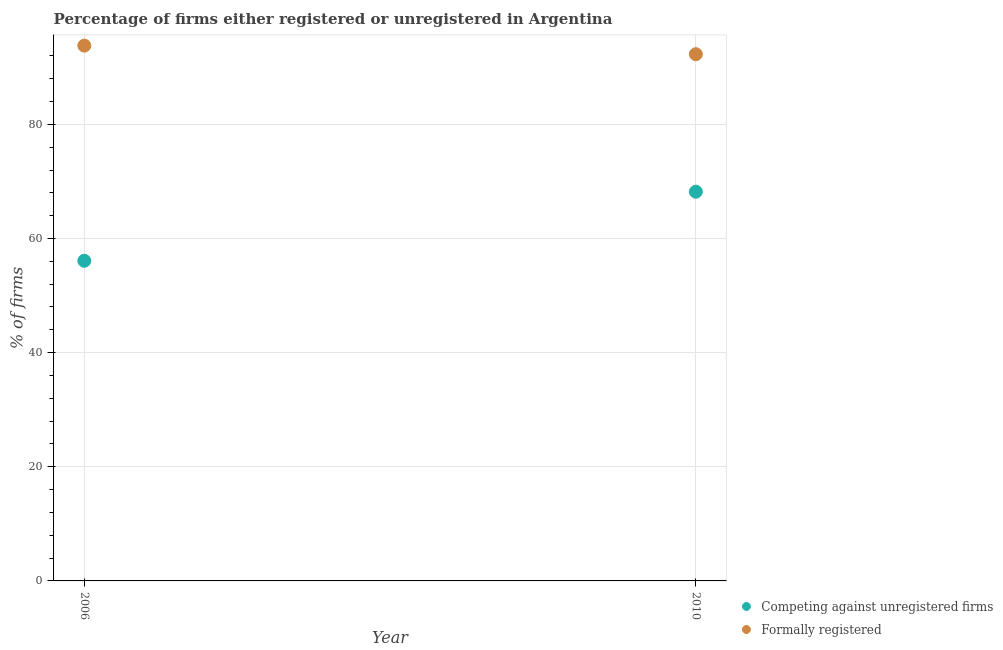Is the number of dotlines equal to the number of legend labels?
Your answer should be compact. Yes. What is the percentage of registered firms in 2006?
Provide a succinct answer. 56.1. Across all years, what is the maximum percentage of formally registered firms?
Your answer should be compact. 93.8. Across all years, what is the minimum percentage of registered firms?
Offer a terse response. 56.1. In which year was the percentage of formally registered firms maximum?
Provide a short and direct response. 2006. In which year was the percentage of formally registered firms minimum?
Make the answer very short. 2010. What is the total percentage of registered firms in the graph?
Your response must be concise. 124.3. What is the difference between the percentage of formally registered firms in 2010 and the percentage of registered firms in 2006?
Your answer should be compact. 36.2. What is the average percentage of formally registered firms per year?
Your answer should be very brief. 93.05. In the year 2010, what is the difference between the percentage of registered firms and percentage of formally registered firms?
Offer a terse response. -24.1. In how many years, is the percentage of formally registered firms greater than 72 %?
Make the answer very short. 2. What is the ratio of the percentage of formally registered firms in 2006 to that in 2010?
Offer a very short reply. 1.02. Is the percentage of formally registered firms in 2006 less than that in 2010?
Offer a very short reply. No. Is the percentage of registered firms strictly greater than the percentage of formally registered firms over the years?
Your response must be concise. No. How many dotlines are there?
Keep it short and to the point. 2. What is the difference between two consecutive major ticks on the Y-axis?
Make the answer very short. 20. Does the graph contain grids?
Your answer should be compact. Yes. Where does the legend appear in the graph?
Provide a short and direct response. Bottom right. How many legend labels are there?
Provide a short and direct response. 2. What is the title of the graph?
Offer a very short reply. Percentage of firms either registered or unregistered in Argentina. What is the label or title of the Y-axis?
Offer a very short reply. % of firms. What is the % of firms of Competing against unregistered firms in 2006?
Offer a very short reply. 56.1. What is the % of firms in Formally registered in 2006?
Your answer should be compact. 93.8. What is the % of firms of Competing against unregistered firms in 2010?
Offer a terse response. 68.2. What is the % of firms in Formally registered in 2010?
Make the answer very short. 92.3. Across all years, what is the maximum % of firms in Competing against unregistered firms?
Provide a short and direct response. 68.2. Across all years, what is the maximum % of firms of Formally registered?
Give a very brief answer. 93.8. Across all years, what is the minimum % of firms in Competing against unregistered firms?
Provide a short and direct response. 56.1. Across all years, what is the minimum % of firms in Formally registered?
Provide a succinct answer. 92.3. What is the total % of firms of Competing against unregistered firms in the graph?
Give a very brief answer. 124.3. What is the total % of firms in Formally registered in the graph?
Your answer should be very brief. 186.1. What is the difference between the % of firms in Competing against unregistered firms in 2006 and that in 2010?
Give a very brief answer. -12.1. What is the difference between the % of firms of Formally registered in 2006 and that in 2010?
Provide a short and direct response. 1.5. What is the difference between the % of firms in Competing against unregistered firms in 2006 and the % of firms in Formally registered in 2010?
Your answer should be compact. -36.2. What is the average % of firms in Competing against unregistered firms per year?
Offer a terse response. 62.15. What is the average % of firms of Formally registered per year?
Your answer should be very brief. 93.05. In the year 2006, what is the difference between the % of firms in Competing against unregistered firms and % of firms in Formally registered?
Keep it short and to the point. -37.7. In the year 2010, what is the difference between the % of firms in Competing against unregistered firms and % of firms in Formally registered?
Keep it short and to the point. -24.1. What is the ratio of the % of firms in Competing against unregistered firms in 2006 to that in 2010?
Offer a terse response. 0.82. What is the ratio of the % of firms in Formally registered in 2006 to that in 2010?
Your answer should be very brief. 1.02. What is the difference between the highest and the second highest % of firms of Competing against unregistered firms?
Make the answer very short. 12.1. What is the difference between the highest and the lowest % of firms in Formally registered?
Your response must be concise. 1.5. 